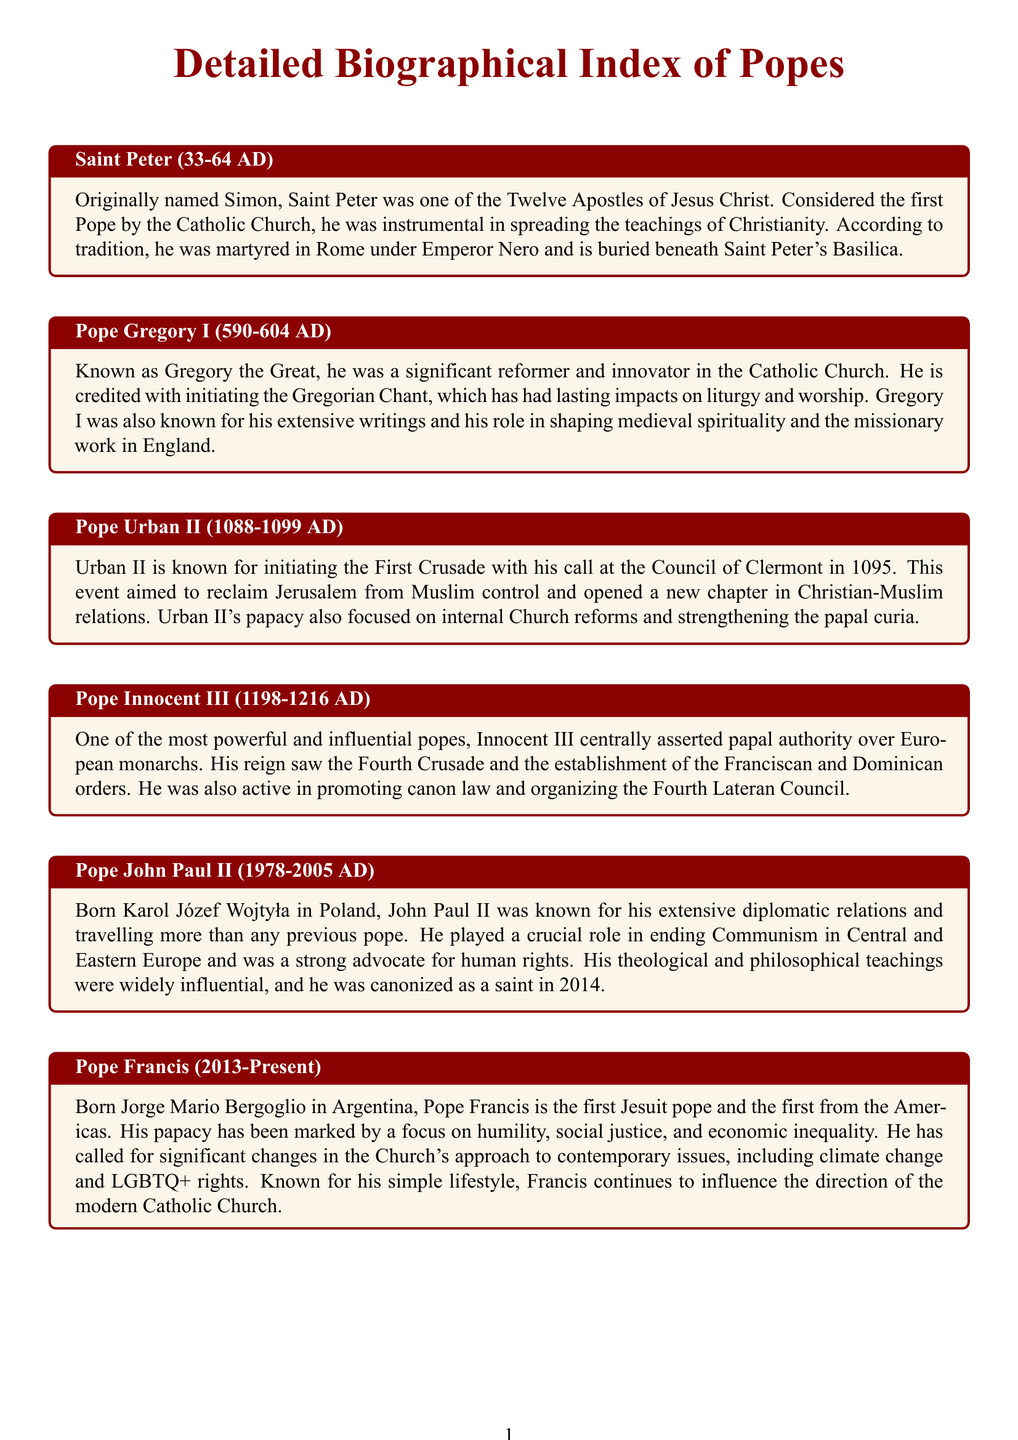What is the duration of Pope Urban II's papacy? The document states that Pope Urban II's papacy lasted from 1088 to 1099 AD.
Answer: 11 years Who is considered the first Pope? According to the document, Saint Peter is regarded as the first Pope by the Catholic Church.
Answer: Saint Peter What significant musical contribution is associated with Pope Gregory I? The document states that Pope Gregory I is credited with initiating the Gregorian Chant.
Answer: Gregorian Chant Which Pope initiated the First Crusade? The document mentions that Pope Urban II is known for initiating the First Crusade.
Answer: Pope Urban II In what year was Pope John Paul II canonized as a saint? The document indicates that Pope John Paul II was canonized as a saint in 2014.
Answer: 2014 What is Pope Francis's birth name? The document reveals that Pope Francis was born Jorge Mario Bergoglio.
Answer: Jorge Mario Bergoglio Which Pope was central in asserting papal authority over European monarchs? According to the document, Pope Innocent III was one of the most powerful and influential popes asserting papal authority.
Answer: Pope Innocent III What is a key focus of Pope Francis's papacy? The document highlights that Pope Francis has a focus on social justice and economic inequality.
Answer: Social justice What significant event did Urban II call for at the Council of Clermont? The document states that Urban II called for the First Crusade.
Answer: First Crusade 